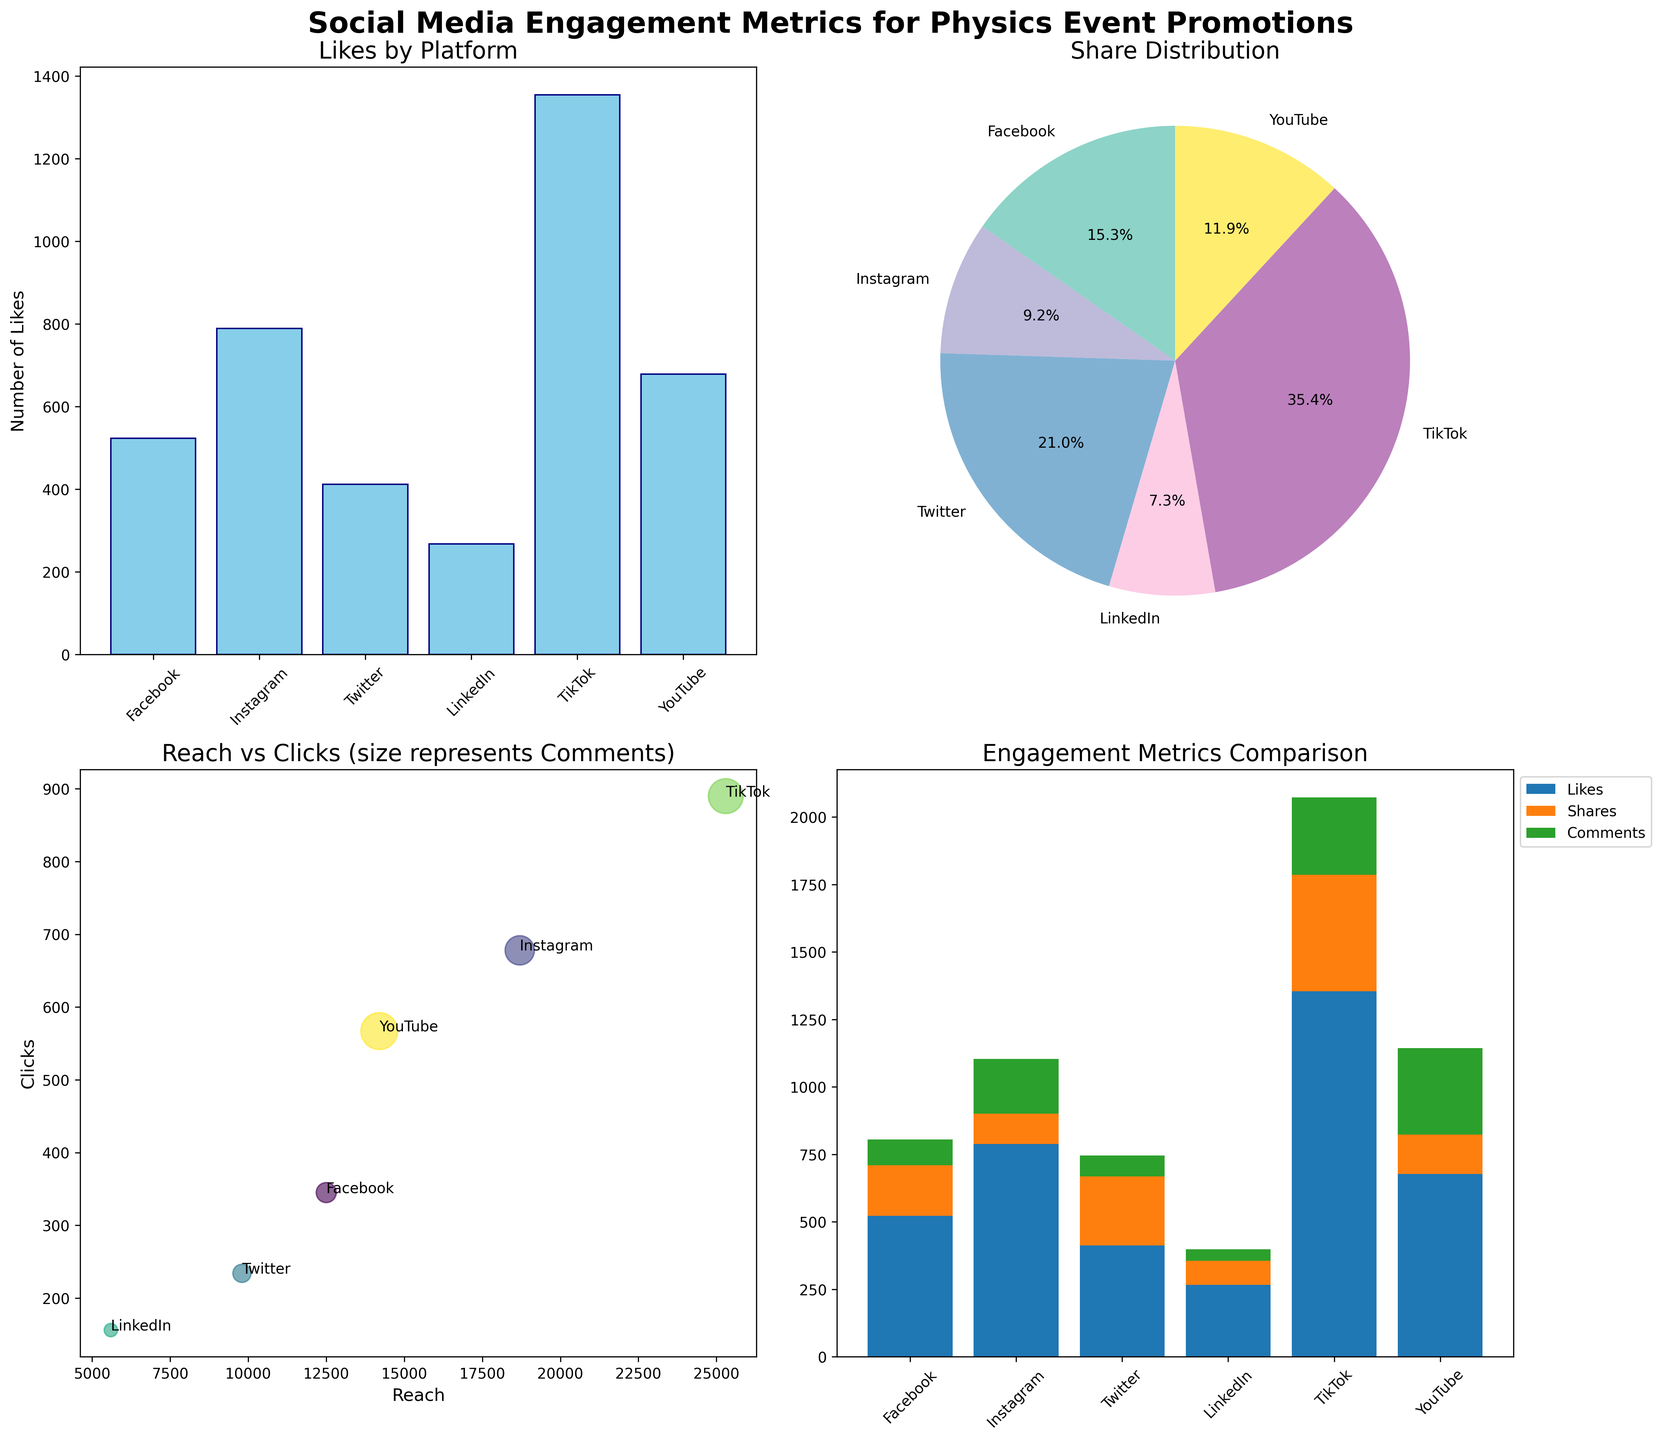What's the most liked platform? By looking at the bar plot titled "Likes by Platform," we see the height of the bars representing the number of likes for each platform. The highest bar in this plot corresponds to TikTok.
Answer: TikTok Which platform has the largest share distribution? The pie chart titled "Share Distribution" provides a visual comparison of shares across platforms. The largest segment represents TikTok, indicating it has the largest share distribution.
Answer: TikTok Which platform has the most comments on YouTube? The scatter plot titled "Reach vs Clicks (size represents Comments)" indicates that the size of the circles represents the number of comments. Since YouTube stands out with the largest circle, it signifies the most comments.
Answer: YouTube What is the combined number of likes for Facebook and Instagram? Referring to the bar plot, the bar heights for Facebook and Instagram represent 523 and 789 likes, respectively. Adding these gives 523 + 789 = 1312.
Answer: 1312 How many shares in total do all platforms have? Look at the pie chart values representing percentages. Calculate by adding all share values: 187 (Facebook) + 112 (Instagram) + 256 (Twitter) + 89 (LinkedIn) + 432 (TikTok) + 145 (YouTube) = 1221.
Answer: 1221 Which platform shows the highest engagement metric when considering Likes, Shares, and Comments together? Look at the stacked bar chart where the highest total engagement is evident by summing the heights of the individual segments. Observing the stacked bars, TikTok has the highest cumulative engagement metric.
Answer: TikTok Which platform's reach resulted in the highest number of clicks? By examining the scatter plot under "Reach vs Clicks," the reach axis and click axis help to identify maximum reach. TikTok has the highest reach and consequently the highest clicks.
Answer: TikTok Compare the number of shares between Twitter and LinkedIn. Which has more? Referring to the pie chart, Twitter's segment is larger than LinkedIn's. Twitter has more shares.
Answer: Twitter 